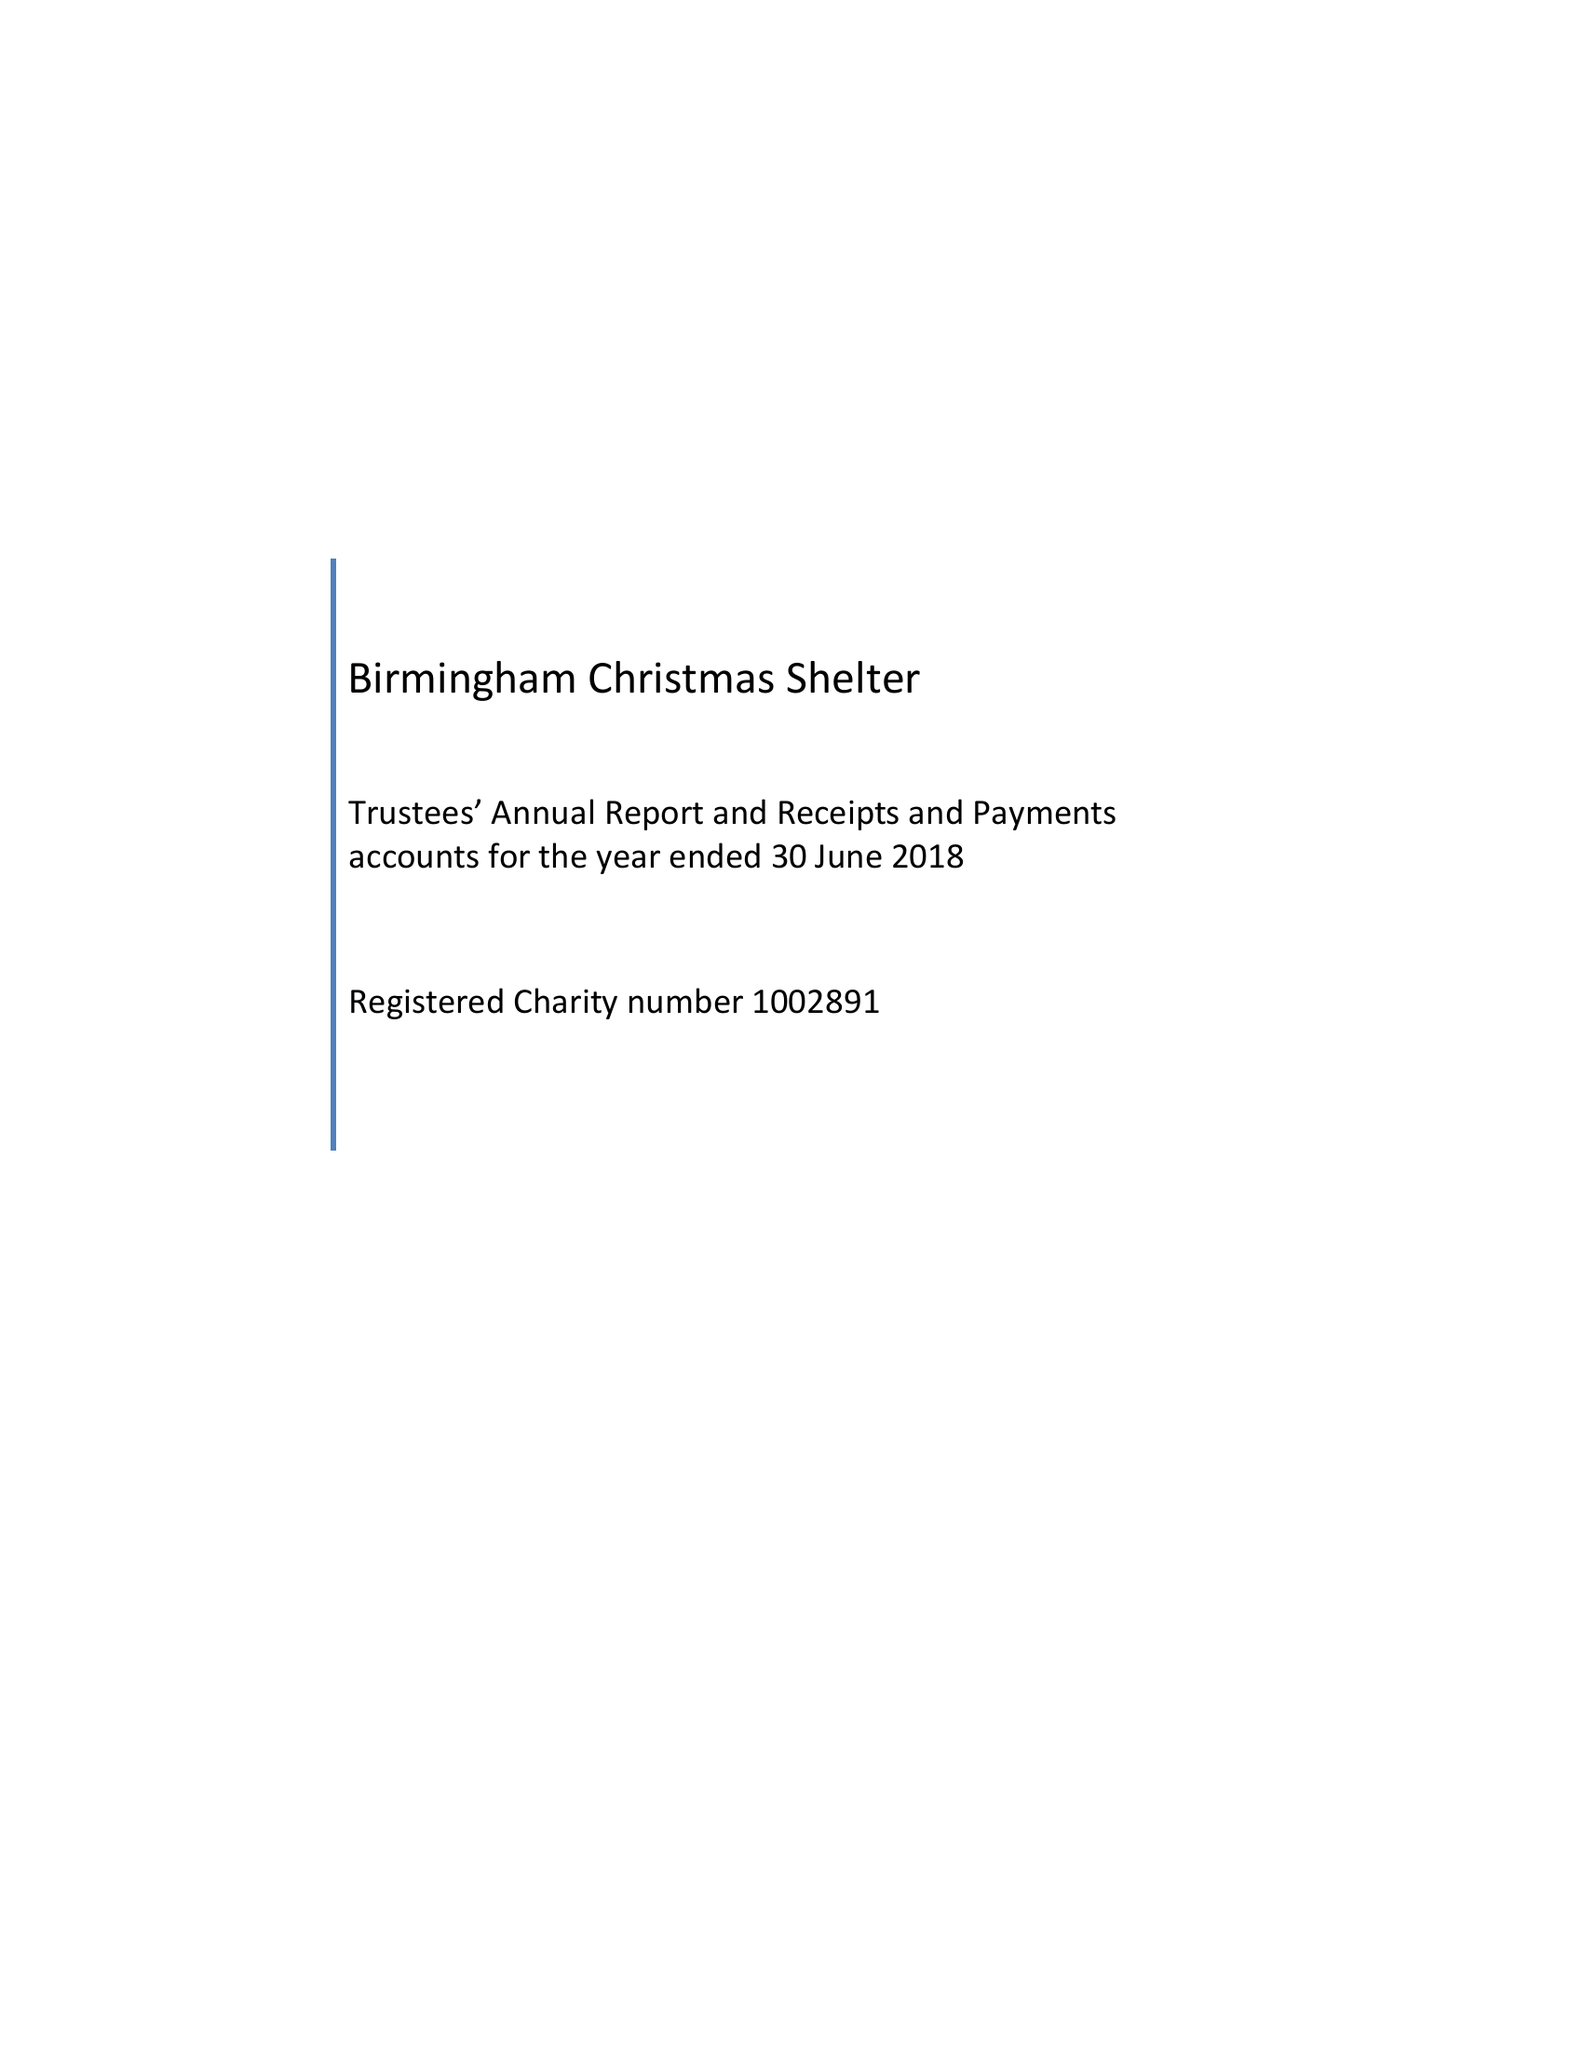What is the value for the address__street_line?
Answer the question using a single word or phrase. PO BOX 17677 